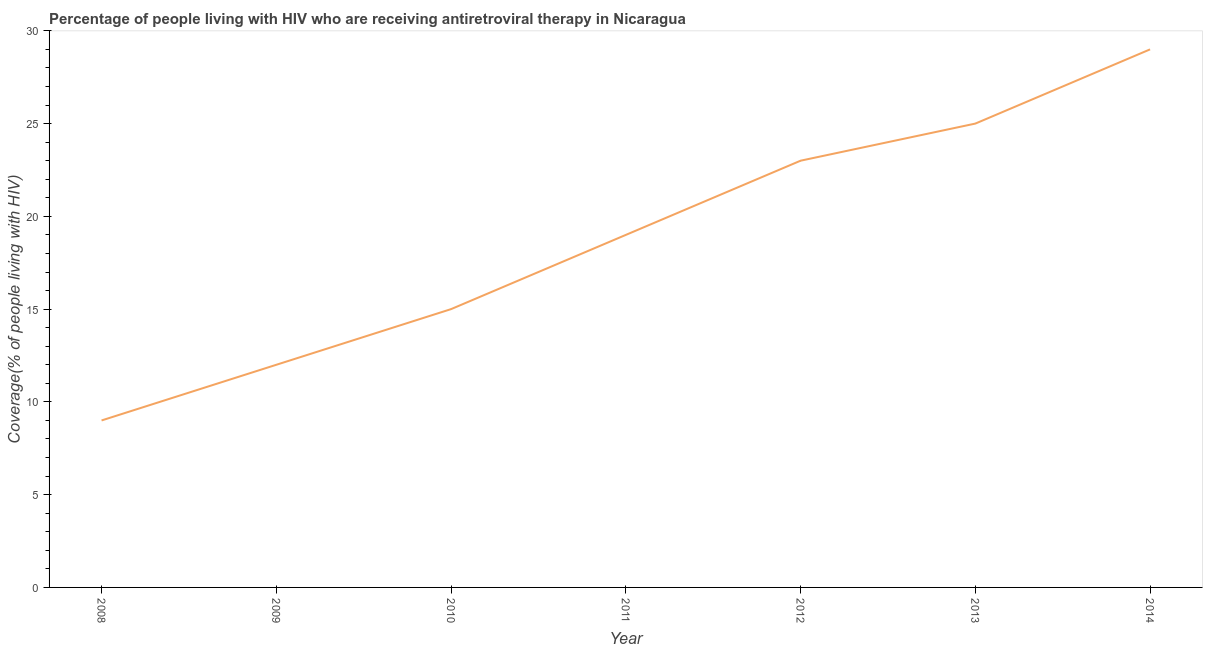What is the antiretroviral therapy coverage in 2009?
Your response must be concise. 12. Across all years, what is the maximum antiretroviral therapy coverage?
Make the answer very short. 29. Across all years, what is the minimum antiretroviral therapy coverage?
Make the answer very short. 9. In which year was the antiretroviral therapy coverage minimum?
Make the answer very short. 2008. What is the sum of the antiretroviral therapy coverage?
Your answer should be compact. 132. What is the difference between the antiretroviral therapy coverage in 2010 and 2011?
Keep it short and to the point. -4. What is the average antiretroviral therapy coverage per year?
Provide a succinct answer. 18.86. Do a majority of the years between 2009 and 2012 (inclusive) have antiretroviral therapy coverage greater than 29 %?
Offer a terse response. No. Is the antiretroviral therapy coverage in 2010 less than that in 2012?
Offer a terse response. Yes. Is the difference between the antiretroviral therapy coverage in 2010 and 2012 greater than the difference between any two years?
Keep it short and to the point. No. What is the difference between the highest and the second highest antiretroviral therapy coverage?
Offer a very short reply. 4. What is the difference between the highest and the lowest antiretroviral therapy coverage?
Offer a terse response. 20. In how many years, is the antiretroviral therapy coverage greater than the average antiretroviral therapy coverage taken over all years?
Offer a very short reply. 4. How many lines are there?
Your response must be concise. 1. Are the values on the major ticks of Y-axis written in scientific E-notation?
Provide a succinct answer. No. What is the title of the graph?
Give a very brief answer. Percentage of people living with HIV who are receiving antiretroviral therapy in Nicaragua. What is the label or title of the Y-axis?
Your response must be concise. Coverage(% of people living with HIV). What is the Coverage(% of people living with HIV) of 2008?
Provide a short and direct response. 9. What is the Coverage(% of people living with HIV) in 2010?
Offer a terse response. 15. What is the Coverage(% of people living with HIV) of 2012?
Your answer should be very brief. 23. What is the difference between the Coverage(% of people living with HIV) in 2008 and 2010?
Your answer should be very brief. -6. What is the difference between the Coverage(% of people living with HIV) in 2008 and 2014?
Keep it short and to the point. -20. What is the difference between the Coverage(% of people living with HIV) in 2009 and 2010?
Offer a very short reply. -3. What is the difference between the Coverage(% of people living with HIV) in 2009 and 2011?
Make the answer very short. -7. What is the difference between the Coverage(% of people living with HIV) in 2009 and 2012?
Make the answer very short. -11. What is the difference between the Coverage(% of people living with HIV) in 2010 and 2012?
Give a very brief answer. -8. What is the difference between the Coverage(% of people living with HIV) in 2010 and 2013?
Your answer should be compact. -10. What is the difference between the Coverage(% of people living with HIV) in 2011 and 2012?
Your response must be concise. -4. What is the difference between the Coverage(% of people living with HIV) in 2011 and 2013?
Offer a terse response. -6. What is the difference between the Coverage(% of people living with HIV) in 2012 and 2013?
Your answer should be compact. -2. What is the difference between the Coverage(% of people living with HIV) in 2012 and 2014?
Your answer should be compact. -6. What is the ratio of the Coverage(% of people living with HIV) in 2008 to that in 2010?
Provide a succinct answer. 0.6. What is the ratio of the Coverage(% of people living with HIV) in 2008 to that in 2011?
Your response must be concise. 0.47. What is the ratio of the Coverage(% of people living with HIV) in 2008 to that in 2012?
Make the answer very short. 0.39. What is the ratio of the Coverage(% of people living with HIV) in 2008 to that in 2013?
Provide a succinct answer. 0.36. What is the ratio of the Coverage(% of people living with HIV) in 2008 to that in 2014?
Offer a very short reply. 0.31. What is the ratio of the Coverage(% of people living with HIV) in 2009 to that in 2011?
Your answer should be compact. 0.63. What is the ratio of the Coverage(% of people living with HIV) in 2009 to that in 2012?
Your answer should be very brief. 0.52. What is the ratio of the Coverage(% of people living with HIV) in 2009 to that in 2013?
Offer a terse response. 0.48. What is the ratio of the Coverage(% of people living with HIV) in 2009 to that in 2014?
Provide a succinct answer. 0.41. What is the ratio of the Coverage(% of people living with HIV) in 2010 to that in 2011?
Your answer should be compact. 0.79. What is the ratio of the Coverage(% of people living with HIV) in 2010 to that in 2012?
Your answer should be compact. 0.65. What is the ratio of the Coverage(% of people living with HIV) in 2010 to that in 2013?
Offer a terse response. 0.6. What is the ratio of the Coverage(% of people living with HIV) in 2010 to that in 2014?
Provide a short and direct response. 0.52. What is the ratio of the Coverage(% of people living with HIV) in 2011 to that in 2012?
Keep it short and to the point. 0.83. What is the ratio of the Coverage(% of people living with HIV) in 2011 to that in 2013?
Offer a very short reply. 0.76. What is the ratio of the Coverage(% of people living with HIV) in 2011 to that in 2014?
Give a very brief answer. 0.66. What is the ratio of the Coverage(% of people living with HIV) in 2012 to that in 2013?
Give a very brief answer. 0.92. What is the ratio of the Coverage(% of people living with HIV) in 2012 to that in 2014?
Your answer should be compact. 0.79. What is the ratio of the Coverage(% of people living with HIV) in 2013 to that in 2014?
Your response must be concise. 0.86. 